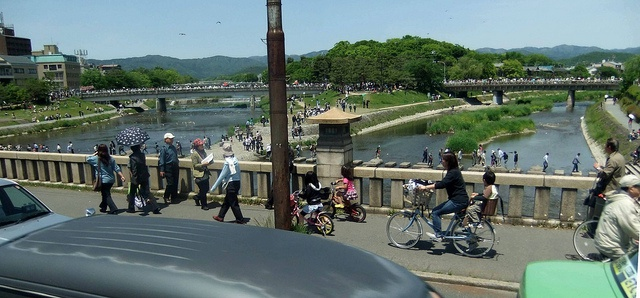Describe the objects in this image and their specific colors. I can see car in lightblue, gray, black, and darkgray tones, people in lightblue, black, gray, and darkgray tones, car in lightblue, aquamarine, teal, and darkgray tones, people in lightblue, darkgray, beige, gray, and lightgray tones, and bicycle in lightblue, gray, black, and darkgray tones in this image. 